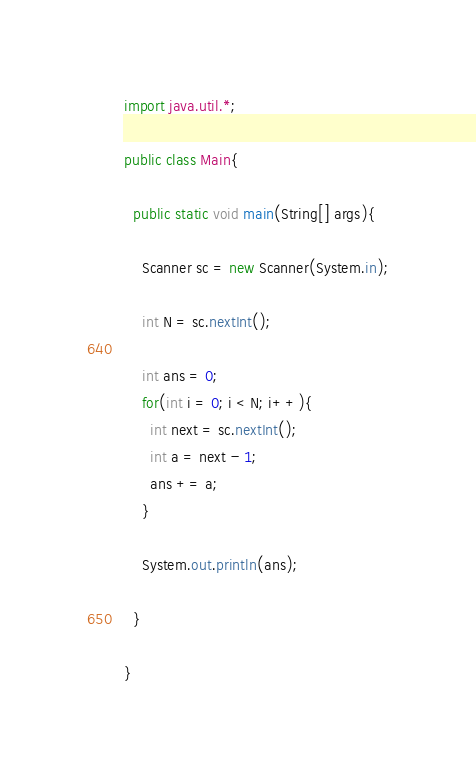Convert code to text. <code><loc_0><loc_0><loc_500><loc_500><_Java_>import java.util.*;

public class Main{
  
  public static void main(String[] args){
    
    Scanner sc = new Scanner(System.in);
    
    int N = sc.nextInt();
    
    int ans = 0;
    for(int i = 0; i < N; i++){
      int next = sc.nextInt();
      int a = next - 1;
      ans += a;
    }
    
    System.out.println(ans);
    
  }
  
}</code> 